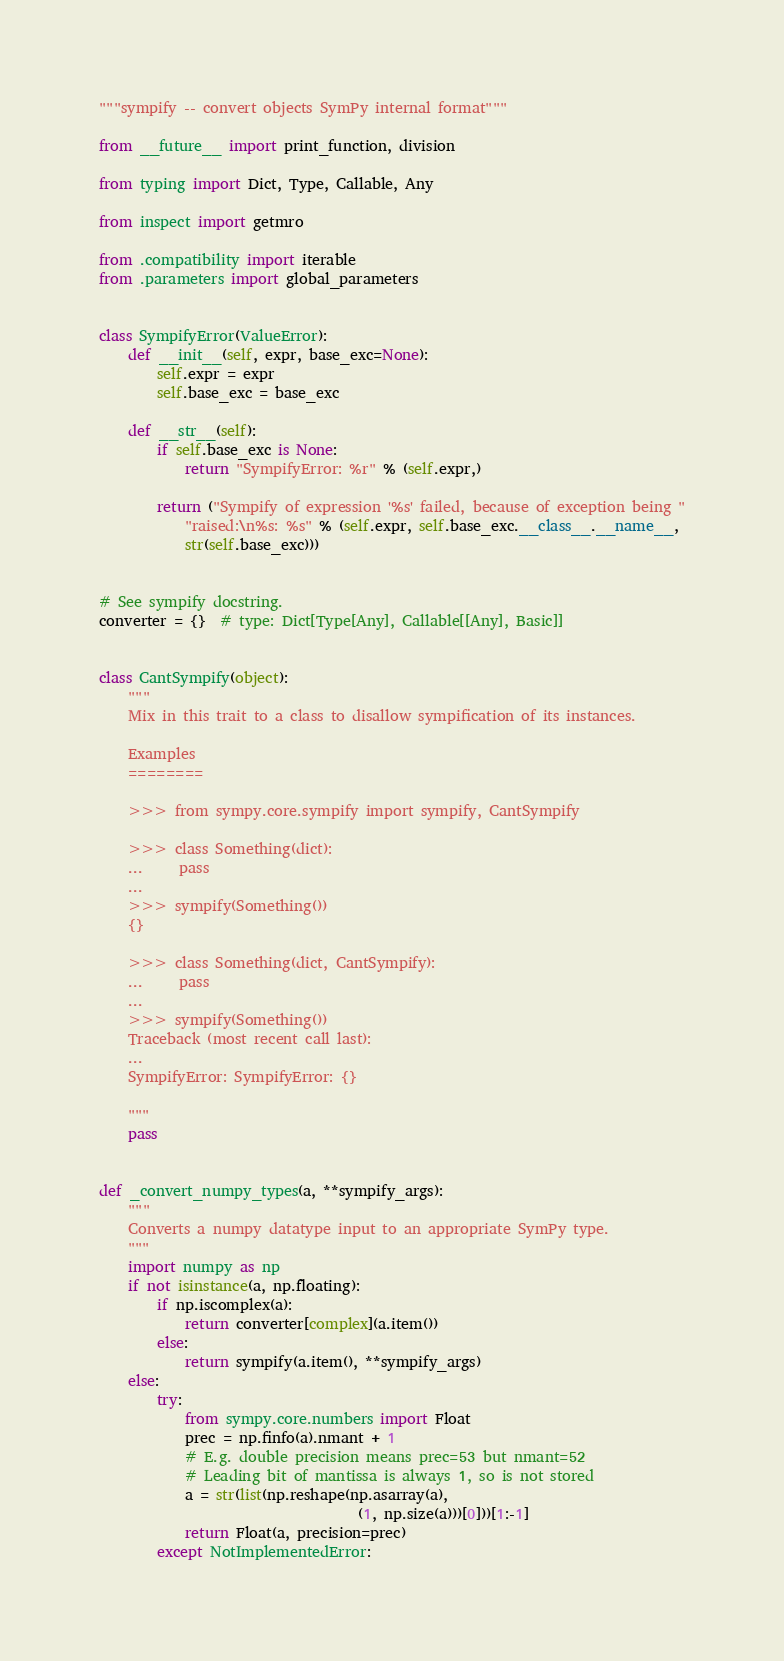<code> <loc_0><loc_0><loc_500><loc_500><_Python_>"""sympify -- convert objects SymPy internal format"""

from __future__ import print_function, division

from typing import Dict, Type, Callable, Any

from inspect import getmro

from .compatibility import iterable
from .parameters import global_parameters


class SympifyError(ValueError):
    def __init__(self, expr, base_exc=None):
        self.expr = expr
        self.base_exc = base_exc

    def __str__(self):
        if self.base_exc is None:
            return "SympifyError: %r" % (self.expr,)

        return ("Sympify of expression '%s' failed, because of exception being "
            "raised:\n%s: %s" % (self.expr, self.base_exc.__class__.__name__,
            str(self.base_exc)))


# See sympify docstring.
converter = {}  # type: Dict[Type[Any], Callable[[Any], Basic]]


class CantSympify(object):
    """
    Mix in this trait to a class to disallow sympification of its instances.

    Examples
    ========

    >>> from sympy.core.sympify import sympify, CantSympify

    >>> class Something(dict):
    ...     pass
    ...
    >>> sympify(Something())
    {}

    >>> class Something(dict, CantSympify):
    ...     pass
    ...
    >>> sympify(Something())
    Traceback (most recent call last):
    ...
    SympifyError: SympifyError: {}

    """
    pass


def _convert_numpy_types(a, **sympify_args):
    """
    Converts a numpy datatype input to an appropriate SymPy type.
    """
    import numpy as np
    if not isinstance(a, np.floating):
        if np.iscomplex(a):
            return converter[complex](a.item())
        else:
            return sympify(a.item(), **sympify_args)
    else:
        try:
            from sympy.core.numbers import Float
            prec = np.finfo(a).nmant + 1
            # E.g. double precision means prec=53 but nmant=52
            # Leading bit of mantissa is always 1, so is not stored
            a = str(list(np.reshape(np.asarray(a),
                                    (1, np.size(a)))[0]))[1:-1]
            return Float(a, precision=prec)
        except NotImplementedError:</code> 